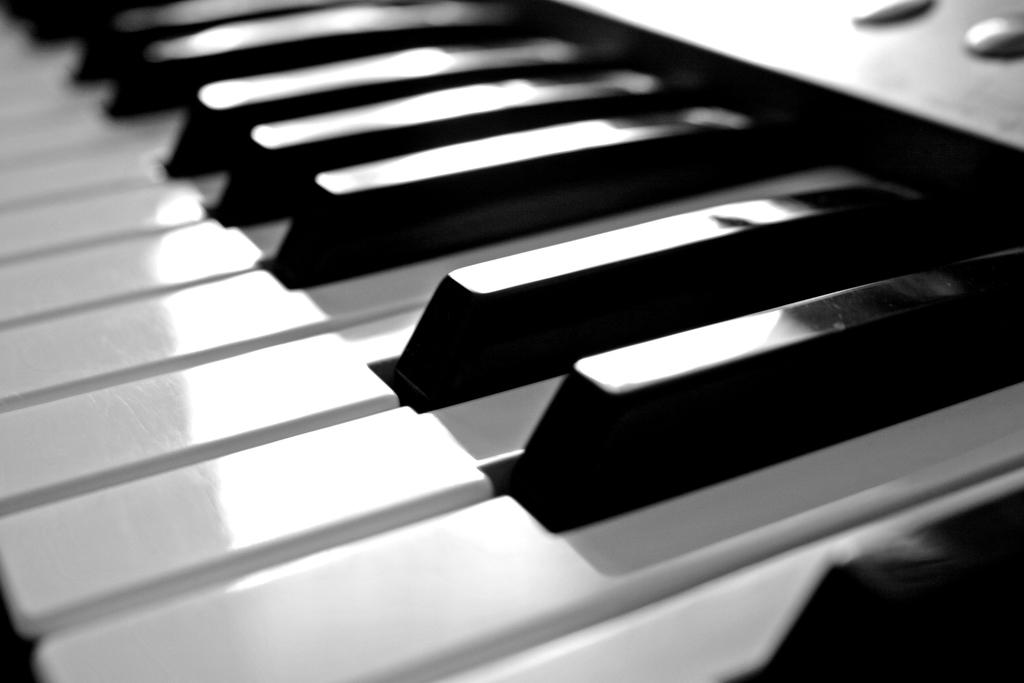What musical instrument is present in the image? There is a piano in the image. What part of the piano is visible in the image? The image shows the piano keys. What type of goldfish can be seen swimming in the image? There are no goldfish present in the image; it features a piano with visible keys. What treatment is being administered to the piano in the image? There is no treatment being administered to the piano in the image; it is simply a piano with visible keys. 